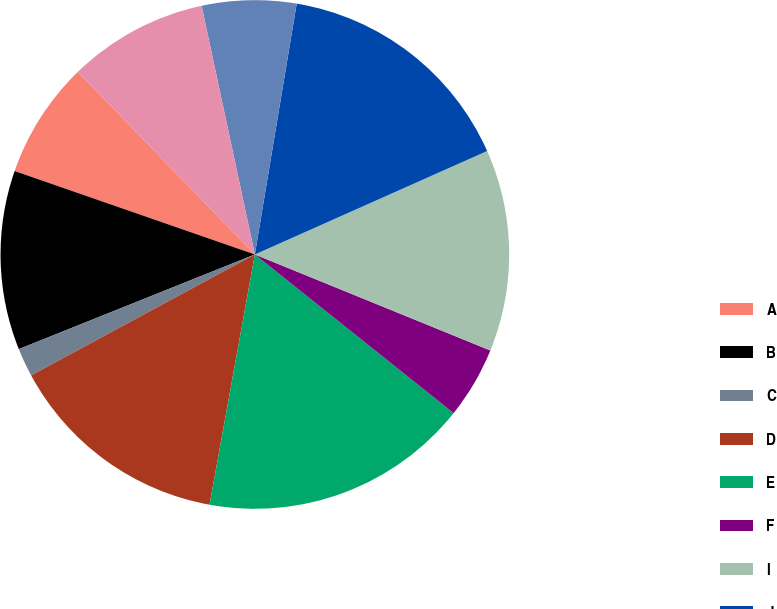<chart> <loc_0><loc_0><loc_500><loc_500><pie_chart><fcel>A<fcel>B<fcel>C<fcel>D<fcel>E<fcel>F<fcel>I<fcel>J<fcel>K<fcel>L<nl><fcel>7.43%<fcel>11.39%<fcel>1.82%<fcel>14.26%<fcel>17.13%<fcel>4.56%<fcel>12.83%<fcel>15.7%<fcel>5.99%<fcel>8.89%<nl></chart> 